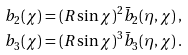<formula> <loc_0><loc_0><loc_500><loc_500>b _ { 2 } ( \chi ) & = ( R \sin \chi ) ^ { 2 } \bar { b } _ { 2 } ( \eta , \chi ) \, , \\ b _ { 3 } ( \chi ) & = ( R \sin \chi ) ^ { 3 } \bar { b } _ { 3 } ( \eta , \chi ) \, .</formula> 